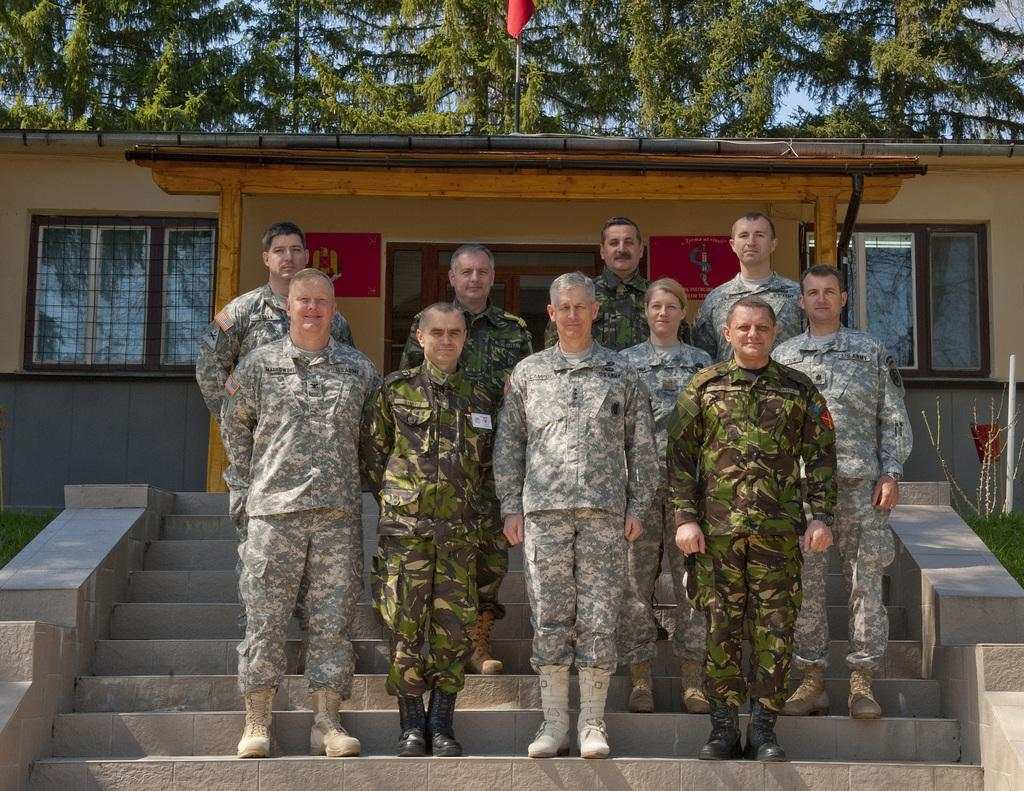What are the people in the image doing? The men and woman in the image are standing on a staircase. Can you describe the gender distribution in the group? There is a woman among the men in the image. What structure is visible behind the group of people? There is a house behind the group of people in the image. What type of vegetation can be seen at the top of the image? Trees are visible at the top of the image. What type of beam is being used by the men in the image? There is no beam present in the image; the men are standing on a staircase. What kind of machine can be seen operating in the background of the image? There is no machine present in the image; it features a house and trees in the background. 